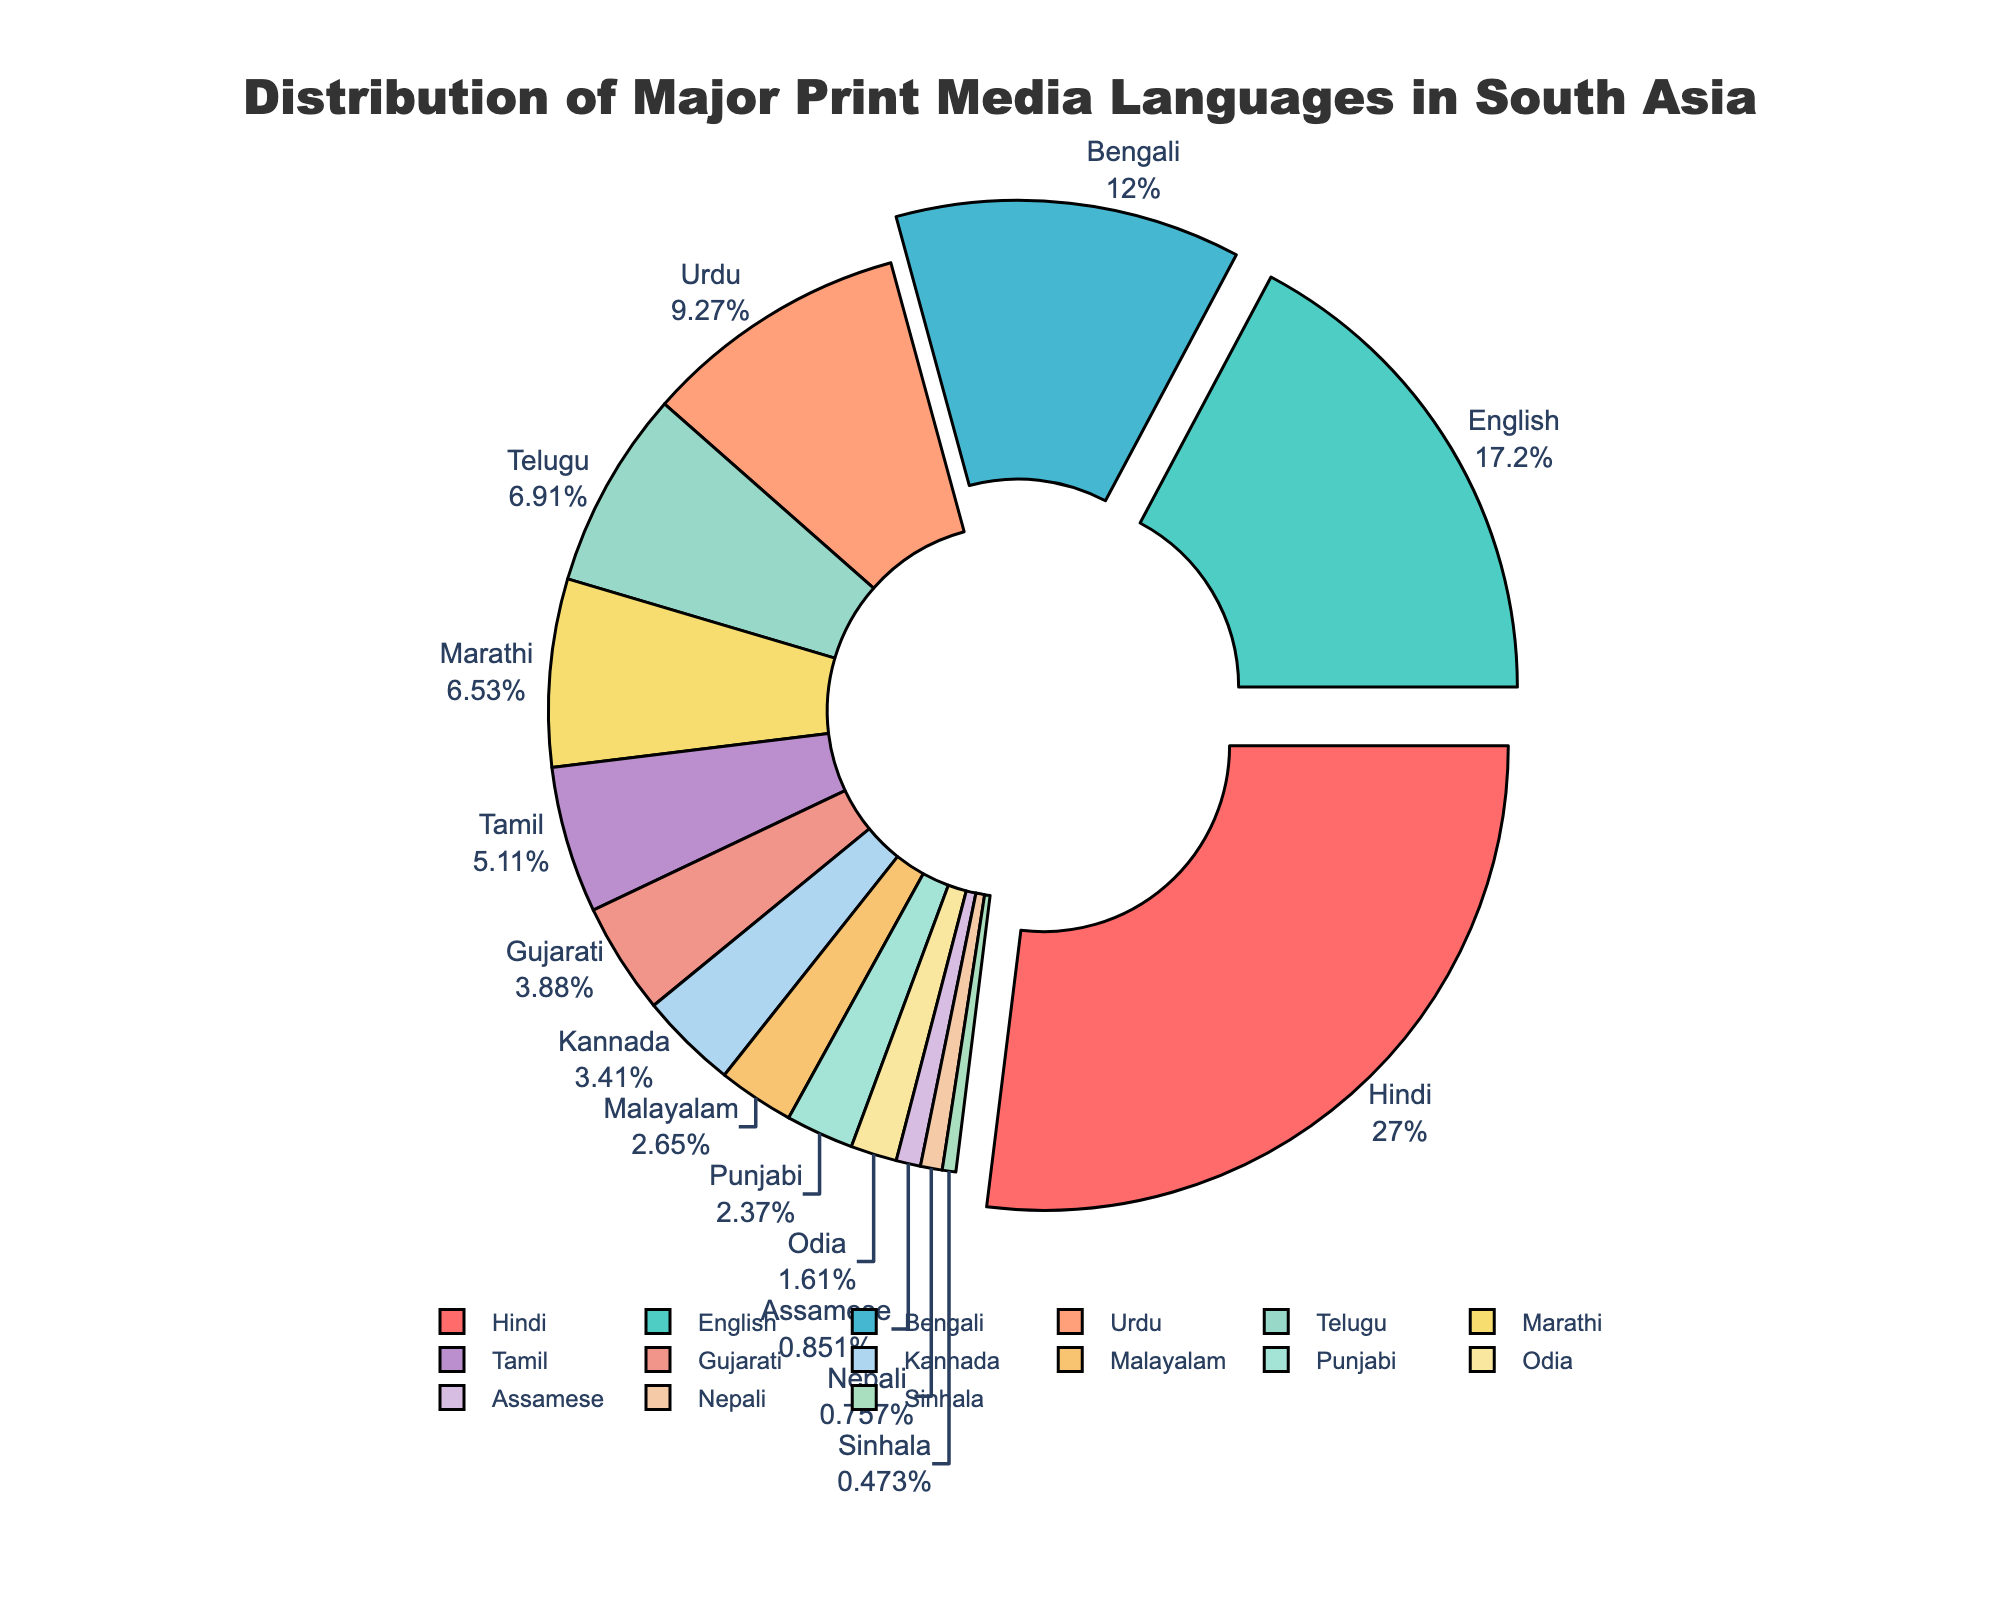What language has the highest percentage representation in the pie chart? Examine the pie chart and identify which slice is the largest. The Hindi language slice is the biggest, indicating that it has the highest percentage.
Answer: Hindi What is the combined percentage of Hindi and English print media? Add the percentage of Hindi (28.5%) and English (18.2%) print media together. 28.5% + 18.2% = 46.7%
Answer: 46.7% Which language has a higher percentage representation, Tamil or Telugu? Compare the percentage slices labeled Tamil and Telugu in the pie chart. Telugu has a higher percentage (7.3%) compared to Tamil (5.4%).
Answer: Telugu What is the sum of the percentages for Marathi, Tamil, and Gujarati print media? Sum the percentages of Marathi, Tamil, and Gujarati: 6.9% + 5.4% + 4.1% = 16.4%
Answer: 16.4% Which three languages have their slices slightly pulled out of the pie, and why might this be done? Look for the three slices that are slightly pulled out from the pie chart. These languages are Hindi, English, and Bengali. Highlighting these slices helps emphasize the top three languages with the highest percentages.
Answer: Hindi, English, Bengali What is the percentage difference between Bengali and Urdu print media? Subtract the percentage of Urdu (9.8%) from the percentage of Bengali (12.7%). 12.7% - 9.8% = 2.9%
Answer: 2.9% What is the total percentage covered by Kannada, Malayalam, and Punjabi print media? Add the percentages of Kannada (3.6%), Malayalam (2.8%), and Punjabi (2.5%). 3.6% + 2.8% + 2.5% = 8.9%
Answer: 8.9% Which color is used to represent English in the pie chart? Identify the color of the slice labeled English in the chart. The color used for English is light blue.
Answer: Light blue Which language has a smaller percentage, Odia or Assamese? Compare the percentages of Odia (1.7%) and Assamese (0.9%). Assamese has a smaller percentage.
Answer: Assamese What is the difference in percentage between the language with the highest representation and the one with the lowest? Subtract the smallest percentage (Sinhala, 0.5%) from the highest percentage (Hindi, 28.5%). 28.5% - 0.5% = 28%
Answer: 28% 